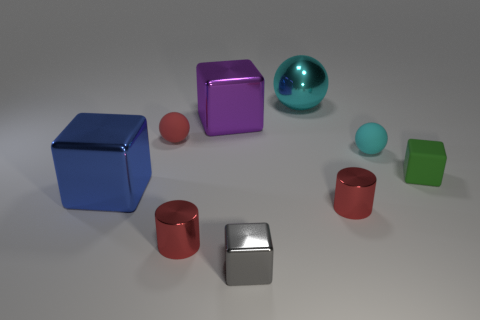What number of tiny cyan shiny things are there?
Provide a short and direct response. 0. What number of spheres are tiny cyan matte things or tiny red objects?
Give a very brief answer. 2. There is a ball on the right side of the large cyan metallic sphere; what number of spheres are on the right side of it?
Provide a short and direct response. 0. Is the material of the gray block the same as the big purple block?
Your response must be concise. Yes. Is there a cube that has the same material as the small red ball?
Offer a very short reply. Yes. There is a large metal cube that is in front of the rubber sphere left of the tiny metallic thing right of the gray block; what is its color?
Ensure brevity in your answer.  Blue. What number of yellow objects are shiny cylinders or metallic balls?
Ensure brevity in your answer.  0. What number of blue metallic things are the same shape as the cyan metal thing?
Ensure brevity in your answer.  0. What shape is the green object that is the same size as the cyan matte sphere?
Your answer should be very brief. Cube. Are there any small red things on the left side of the small red matte thing?
Keep it short and to the point. No. 